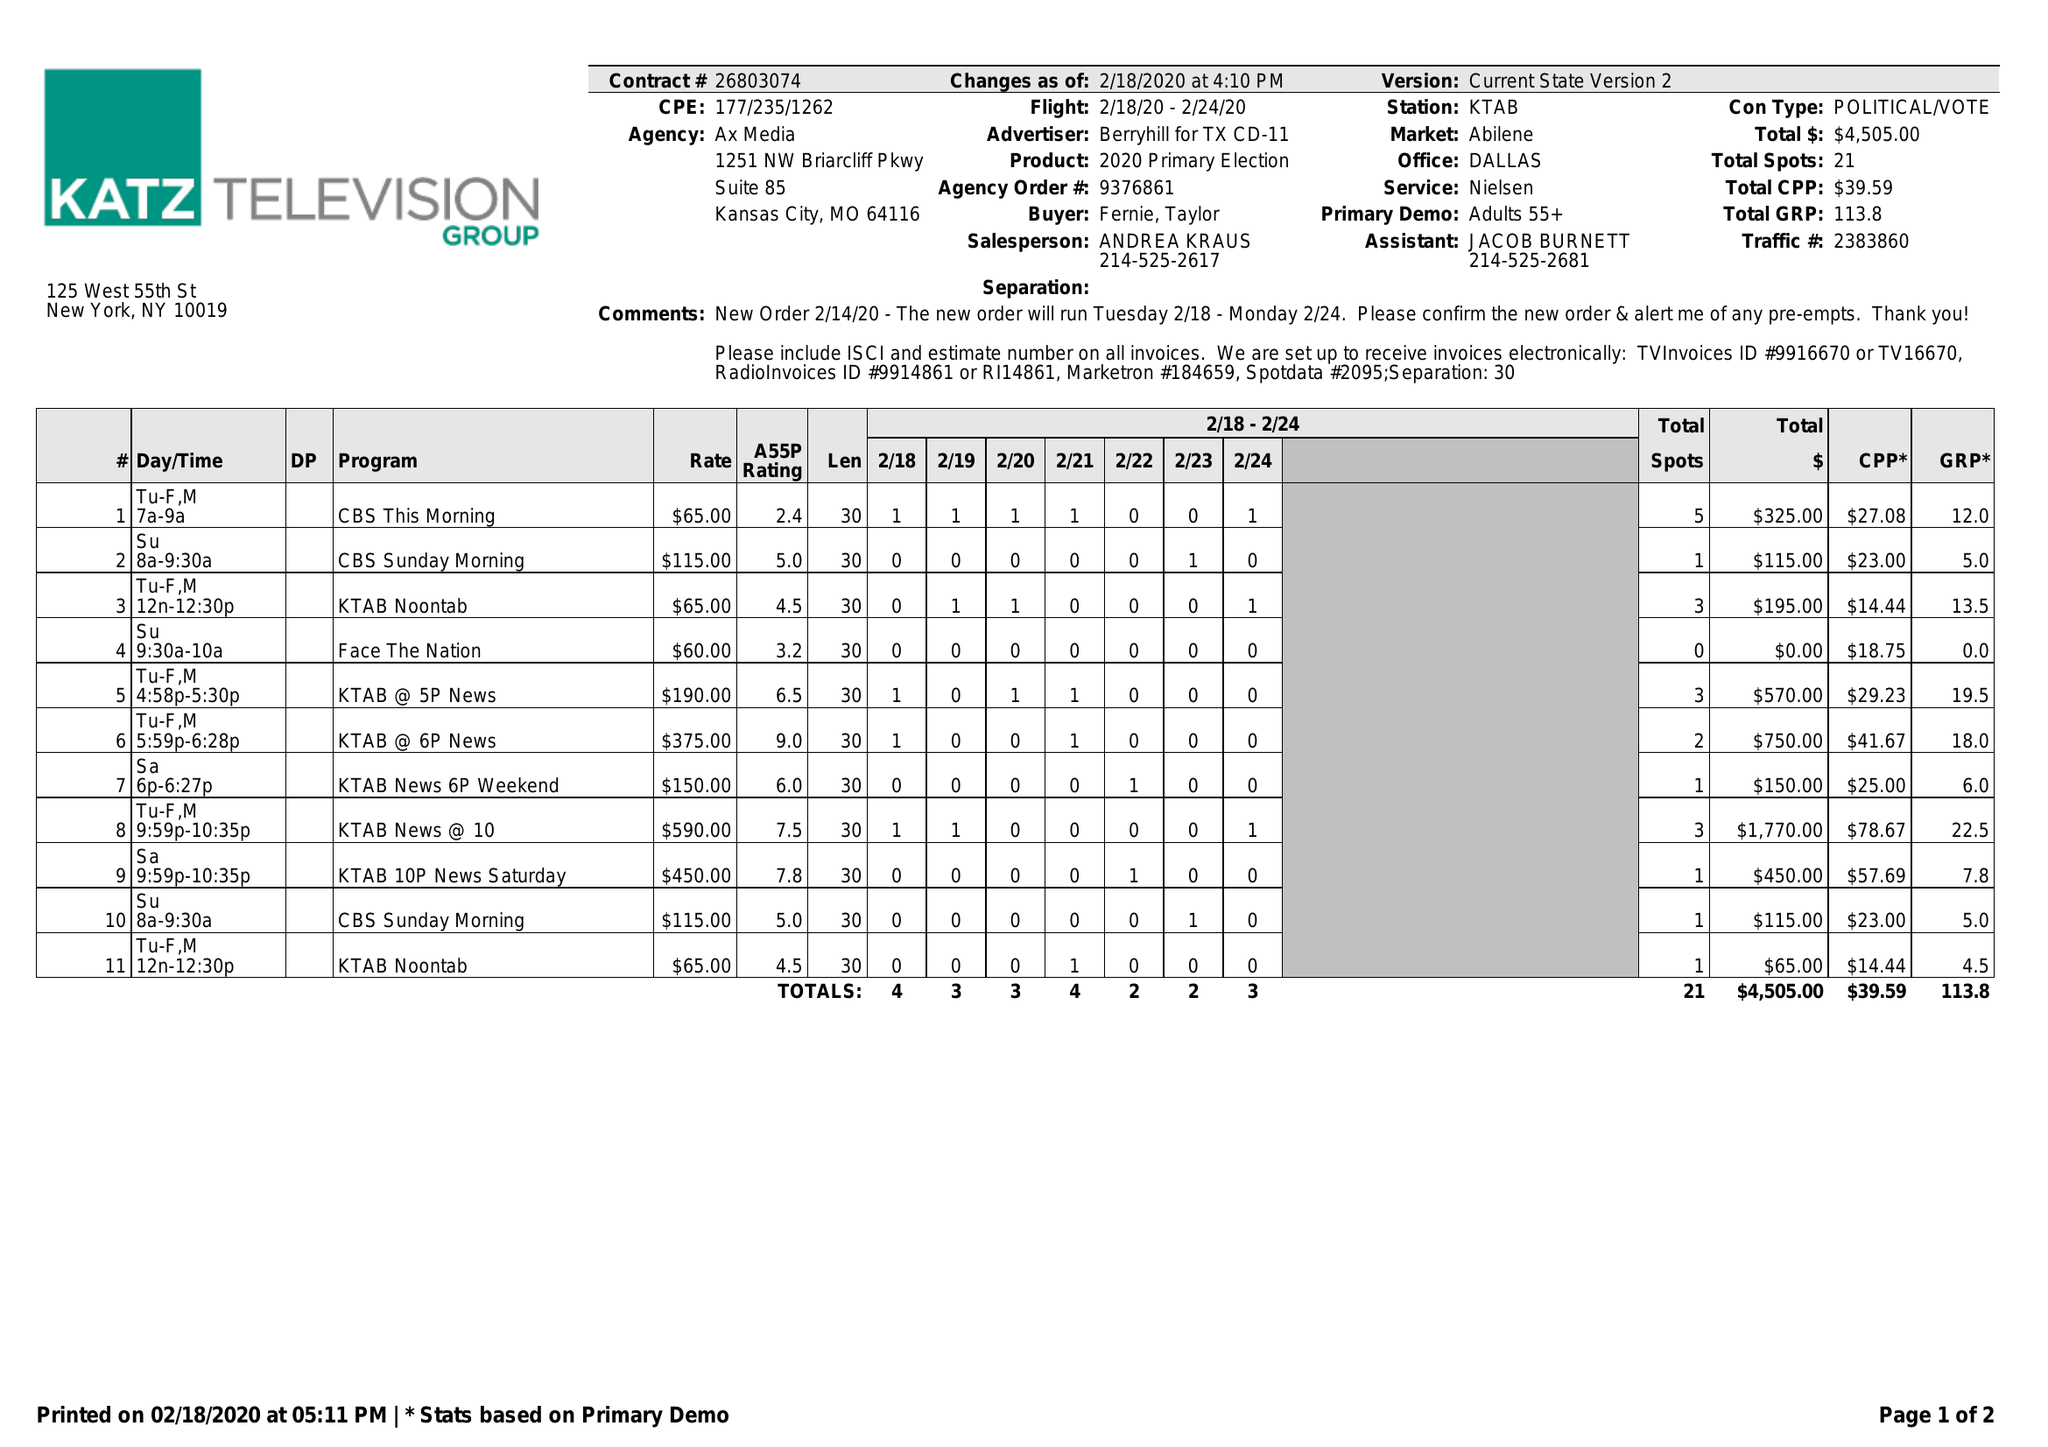What is the value for the flight_to?
Answer the question using a single word or phrase. 02/24/20 